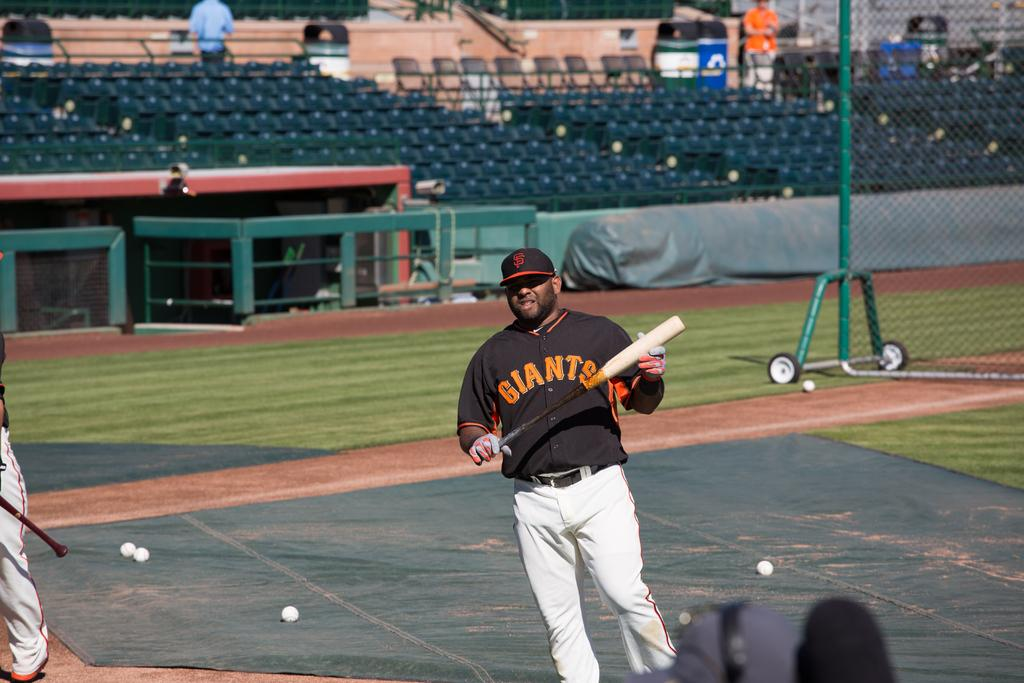<image>
Provide a brief description of the given image. Baseball player holding a bat in a black jersey with Giants on the front in orange. 